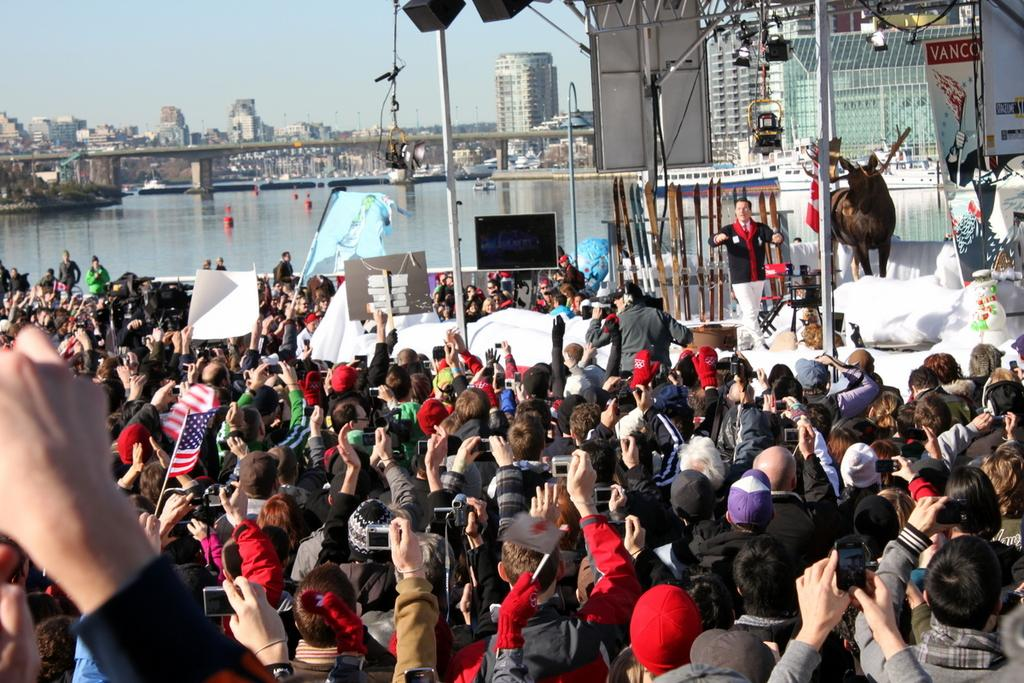How many people are in the image? There are people in the image, but the exact number is not specified. What are some people doing in the image? Some people are holding phones in the image. What type of natural elements can be seen in the image? There are trees in the image. What type of man-made structures can be seen in the image? There are buildings in the image. What type of architectural feature is present in the image? There is a bridge over water in the image. What type of bread is being used as an instrument by the achiever in the image? There is no achiever, bread, or instrument present in the image. 